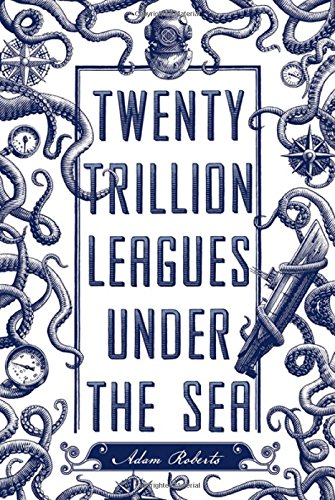Is this a sci-fi book? Yes, it is a science fiction book that delves into speculative scenarios likely involving advanced technologies, exploration, and perhaps engagement with the unknown depths of the ocean. 